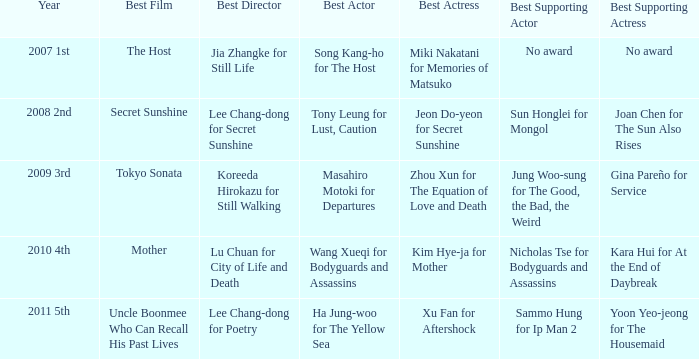Which actor delivered the best performance in the film uncle boonmee who can recall his past lives? Ha Jung-woo for The Yellow Sea. 